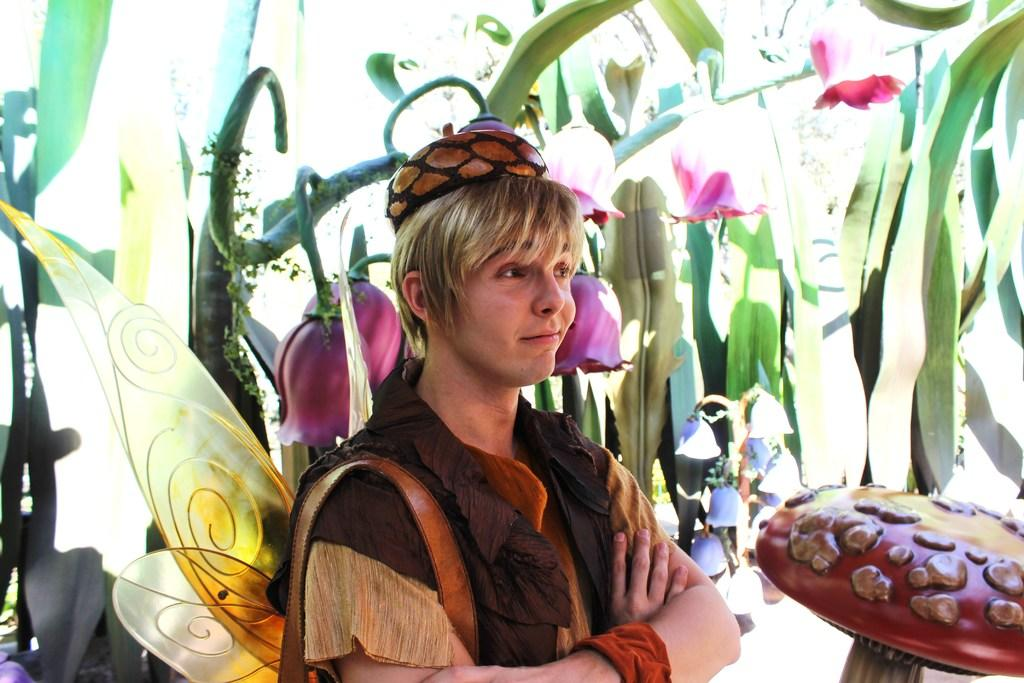What is the main subject of the image? There is a person standing in the image. What distinguishing feature does the person have? The person has wings. What can be seen in the background of the image? There are trees and flowers in the background of the image. What other object is present in the image? There is a mushroom in the image. What type of screw can be seen holding the person's wings together in the image? There is no screw visible in the image; the person's wings are not held together by any visible fasteners. 